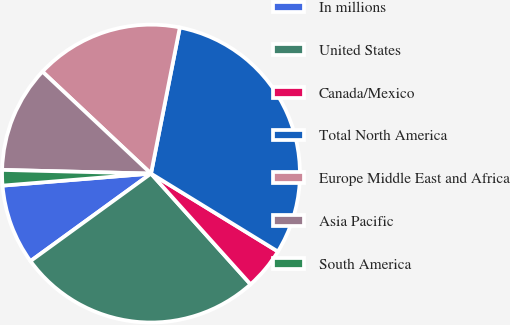Convert chart. <chart><loc_0><loc_0><loc_500><loc_500><pie_chart><fcel>In millions<fcel>United States<fcel>Canada/Mexico<fcel>Total North America<fcel>Europe Middle East and Africa<fcel>Asia Pacific<fcel>South America<nl><fcel>8.71%<fcel>26.66%<fcel>4.58%<fcel>30.67%<fcel>16.1%<fcel>11.61%<fcel>1.68%<nl></chart> 